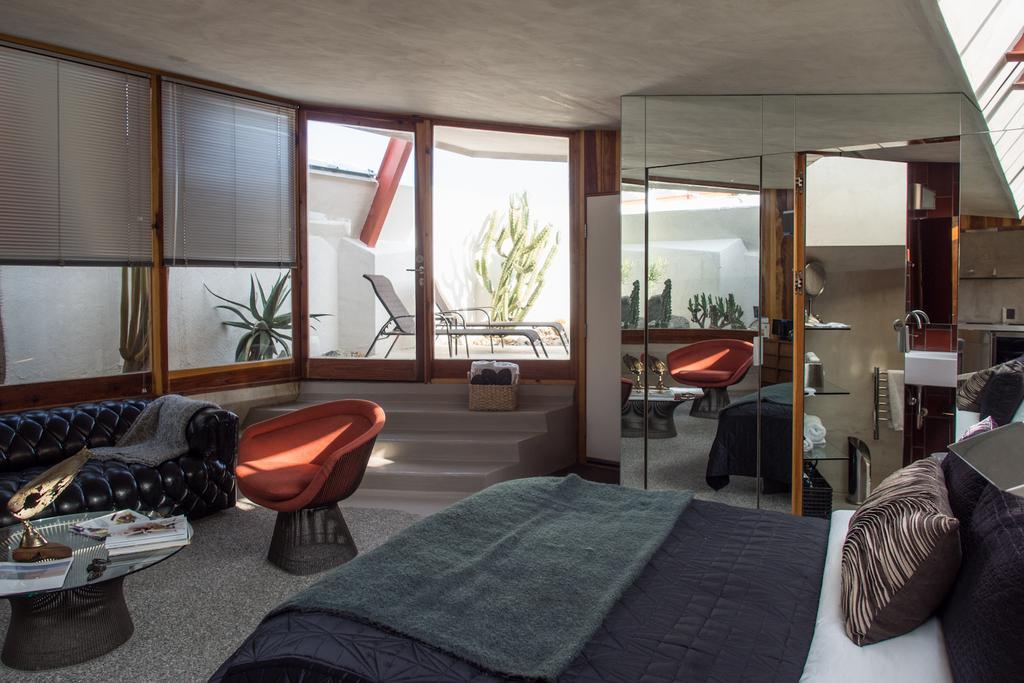Please provide a concise description of this image. In this picture we can see a room with furniture such as sofa, chair, table and on table we have books, some statue bed and on bed there is bed sheet, pillows, doors, racks, chairs, basket, steps. 